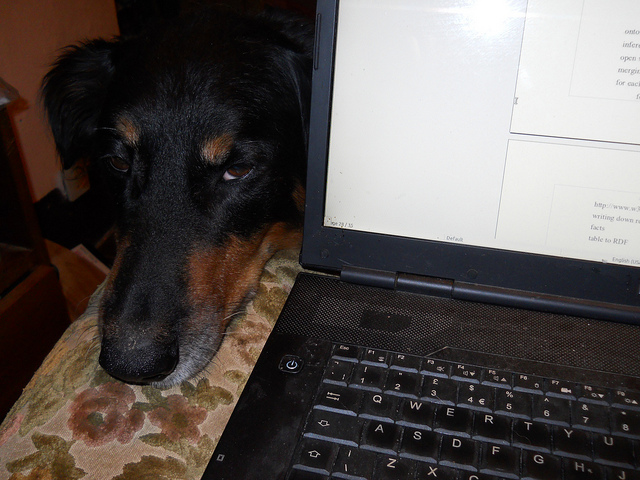Please transcribe the text in this image. Q w E R t 3 2 4 5 6 7 U Y J H G F D X Z S A 